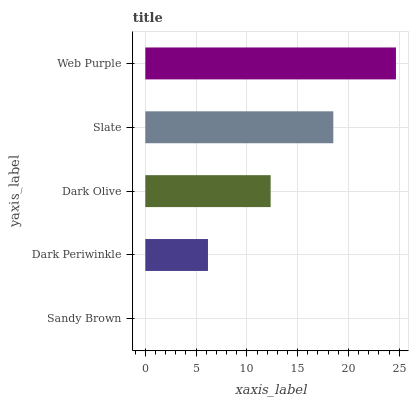Is Sandy Brown the minimum?
Answer yes or no. Yes. Is Web Purple the maximum?
Answer yes or no. Yes. Is Dark Periwinkle the minimum?
Answer yes or no. No. Is Dark Periwinkle the maximum?
Answer yes or no. No. Is Dark Periwinkle greater than Sandy Brown?
Answer yes or no. Yes. Is Sandy Brown less than Dark Periwinkle?
Answer yes or no. Yes. Is Sandy Brown greater than Dark Periwinkle?
Answer yes or no. No. Is Dark Periwinkle less than Sandy Brown?
Answer yes or no. No. Is Dark Olive the high median?
Answer yes or no. Yes. Is Dark Olive the low median?
Answer yes or no. Yes. Is Web Purple the high median?
Answer yes or no. No. Is Slate the low median?
Answer yes or no. No. 